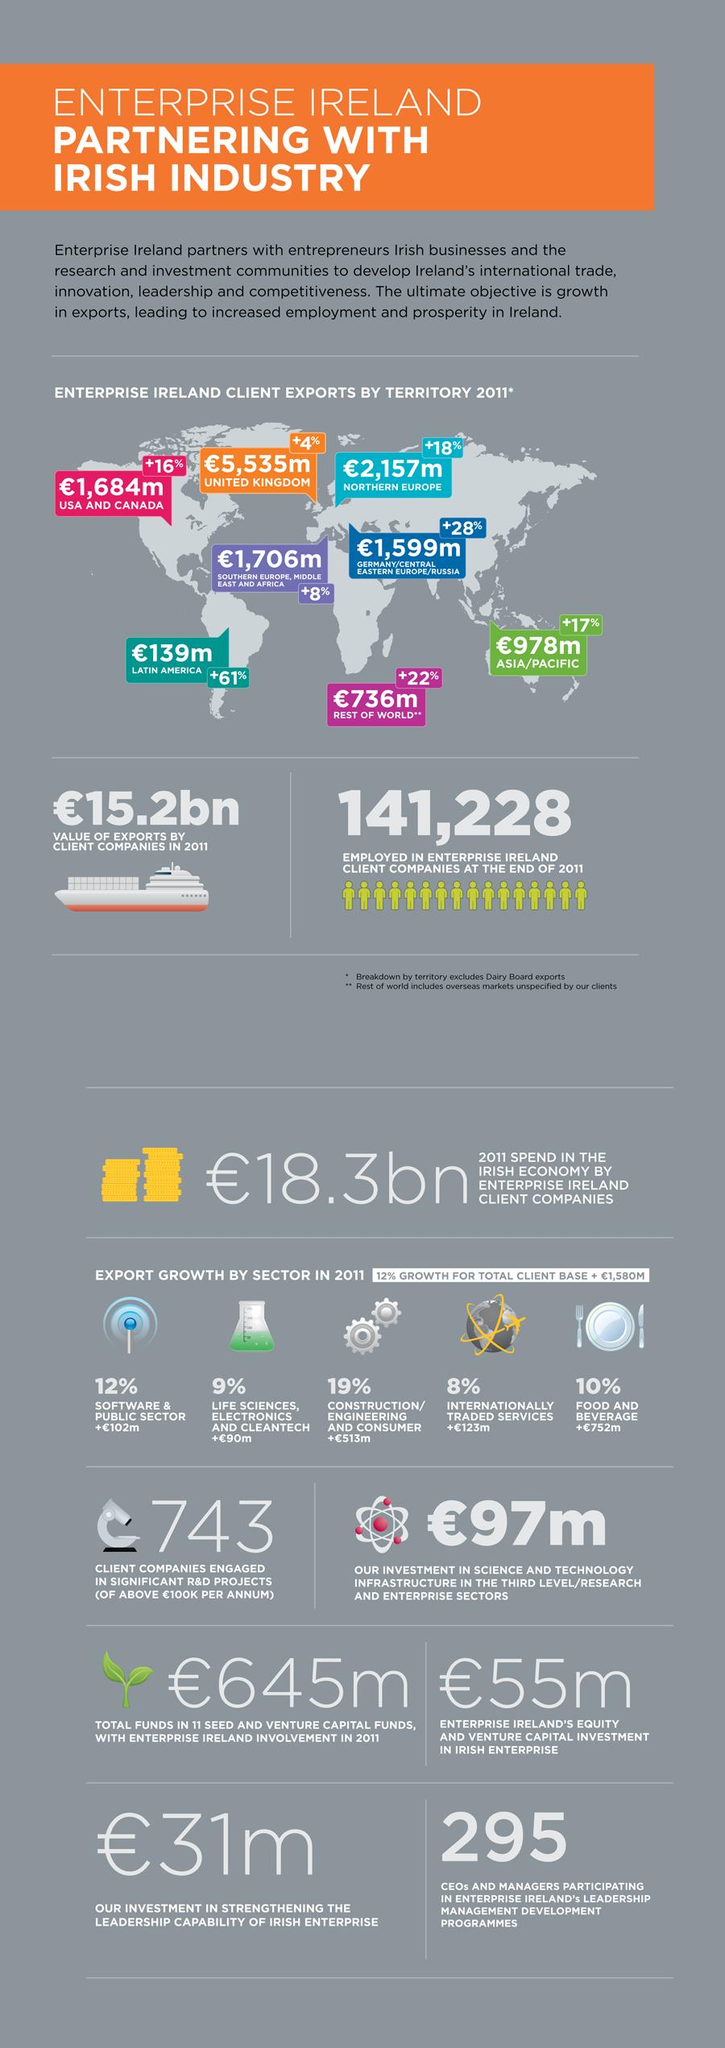Give some essential details in this illustration. The United Kingdom was the country with the highest export in 2011. In 2011, the construction/engineering and consumer goods sector had the highest export growth. The country with the highest percentage increase in export was Latin America. 